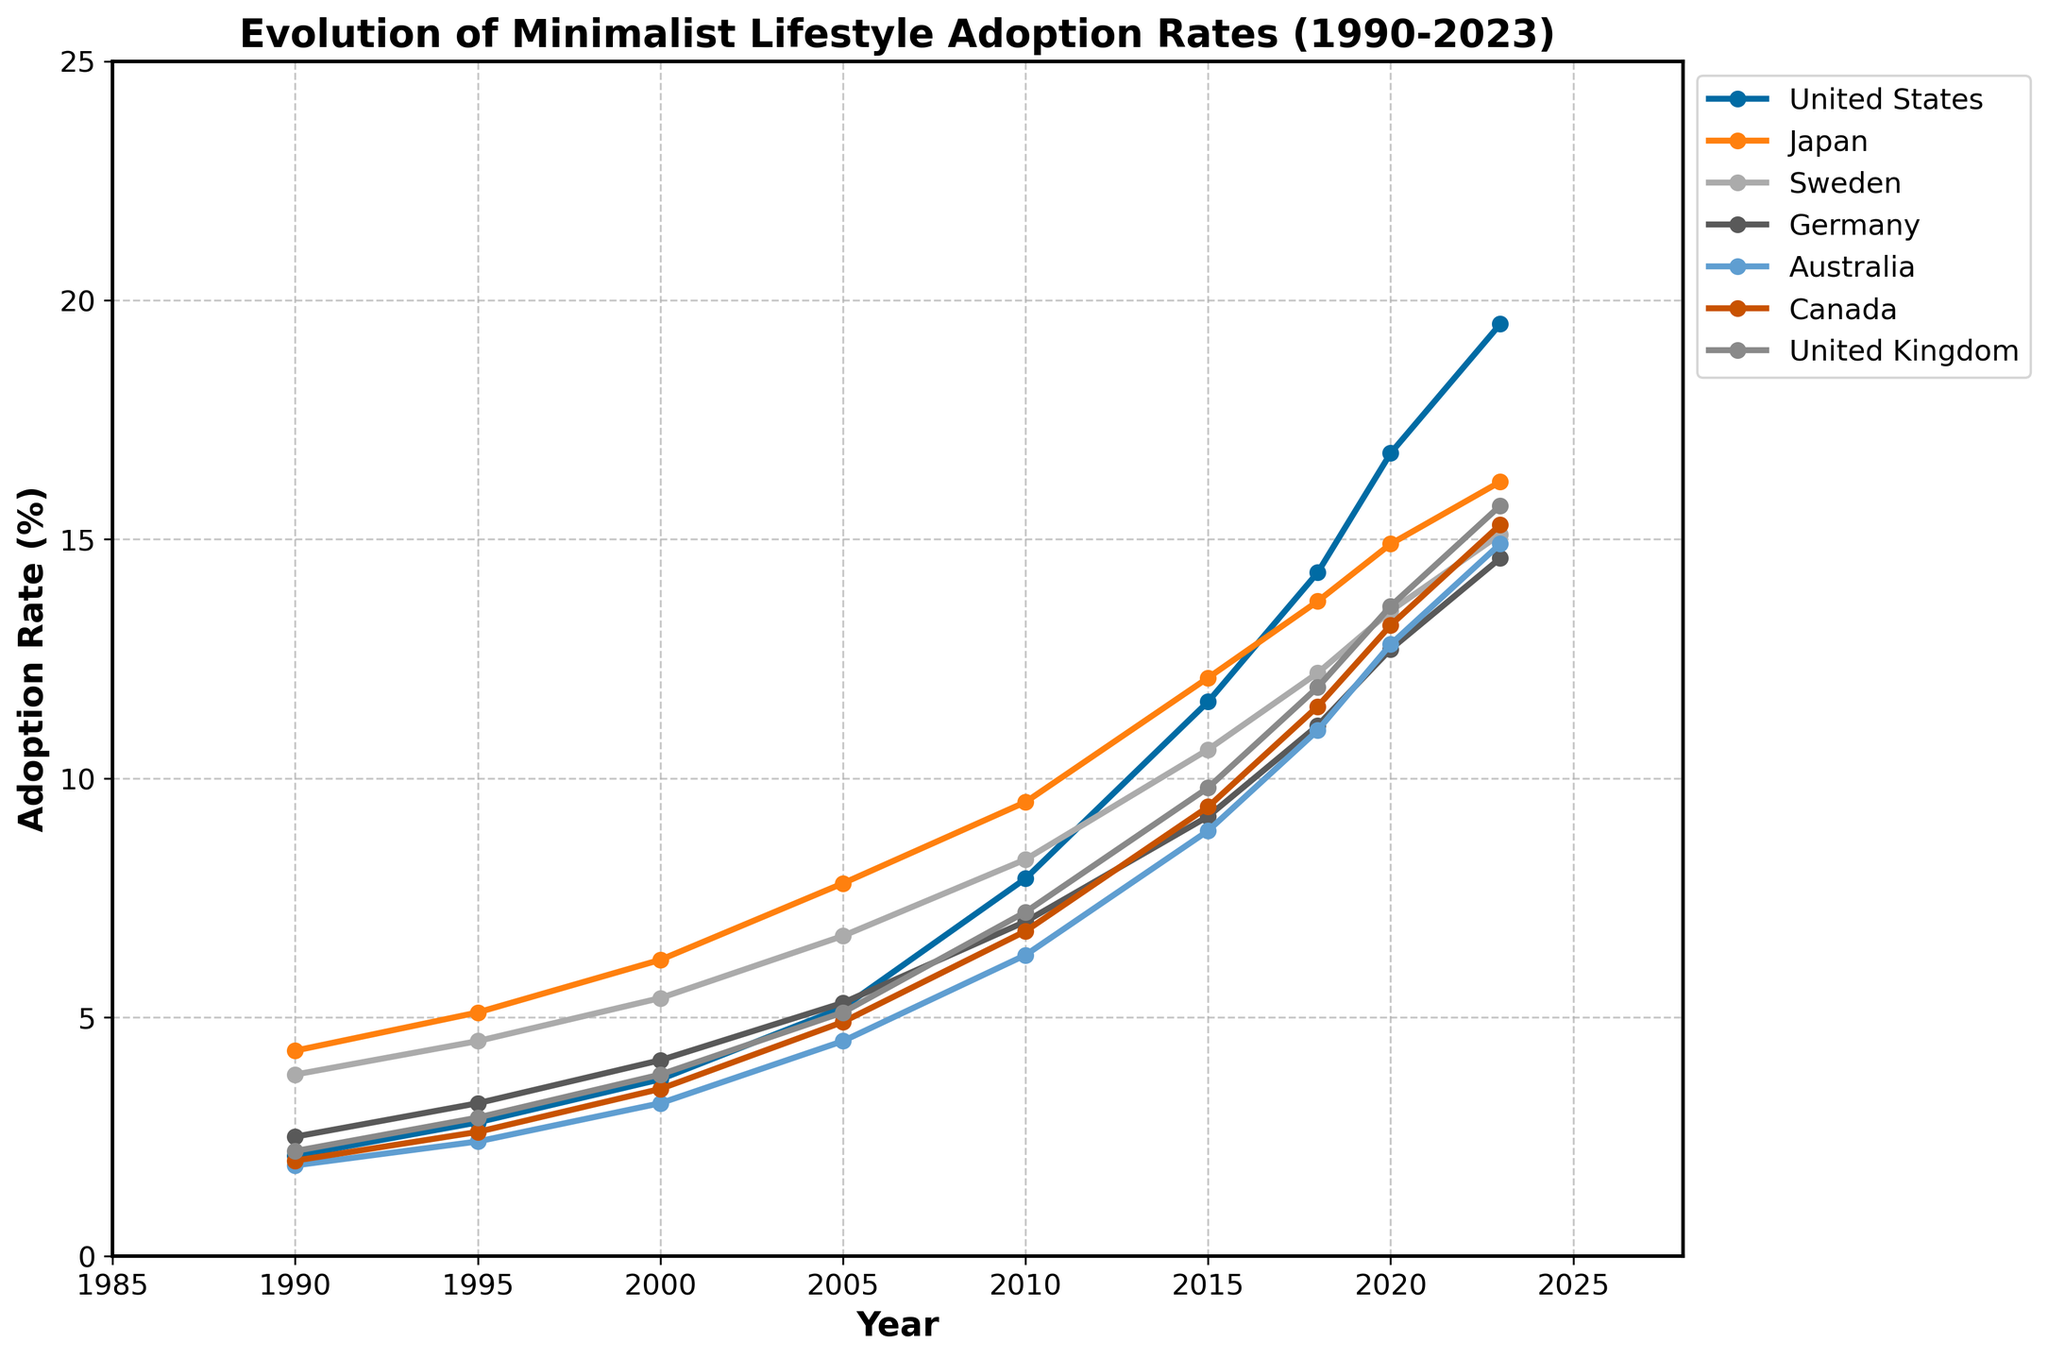What is the trend in minimalist lifestyle adoption rates for Japan from 1990 to 2023? Observing the line chart for Japan, we can see a steady increase in the adoption rate, starting from 4.3% in 1990 and rising to 16.2% in 2023. The trend is positive with a notable uptick in growth between 2005 and 2015.
Answer: Steady increase Which country had the highest adoption rate in 2023? From the line chart, the United States has the highest adoption rate among all countries in 2023, with an adoption rate of 19.5%.
Answer: United States How do the adoption rates of the United States in 2000 and 2010 compare? According to the chart, the adoption rate in the United States was 3.7% in 2000 and increased significantly to 7.9% in 2010, showing a doubling in the rate over this ten-year period.
Answer: The rate doubled Between 2005 and 2015, which country observed the highest increase in adoption rate? To find this, we look at the differences in adoption rates between 2005 and 2015 for each country. Japan increased from 7.8% to 12.1%, so the increase is 4.3 percentage points. Comparing the other countries, the United States saw a rise from 5.2% to 11.6%, an increase of 6.4 percentage points, which is the highest among all.
Answer: United States What is the average adoption rate of minimalism in 2023 across all the listed countries? To find the average, sum the adoption rates in 2023 for all countries and divide by the number of countries. Sum: 19.5 + 16.2 + 15.1 + 14.6 + 14.9 + 15.3 + 15.7 = 111.3. There are 7 countries, so the average = 111.3 / 7 = 15.9%.
Answer: 15.9% How does the adoption rate in Sweden in 1990 compare with that in Australia in 1990? In 1990, Sweden's adoption rate was 3.8%, while Australia's adoption rate was 1.9%. Thus, Sweden's adoption rate was exactly double that of Australia in 1990.
Answer: Double Which country had the most stable (least volatile) adoption rate growth from 1990 to 2023? By visually inspecting the trends, Japan and Germany show relatively smooth and steady lines without sharp increases or decreases. Compared to the other countries, these lines are less volatile. However, to choose one, Japan has a more incremental and consistent growth pattern.
Answer: Japan In which year did Canada surpass the 10% adoption rate? Observing the line for Canada, it can be seen that in 2015, the adoption rate was 9.4%, and by 2018 it had risen to 11.5%. Hence, Canada surpassed the 10% adoption rate between these years, specifically by 2018.
Answer: 2018 What was the total increase in adoption rate for Germany between 1990 and 2023? Germany's adoption rates were 2.5% in 1990 and increased to 14.6% by 2023. The total increase can be calculated as 14.6 - 2.5 = 12.1 percentage points.
Answer: 12.1 percentage points 